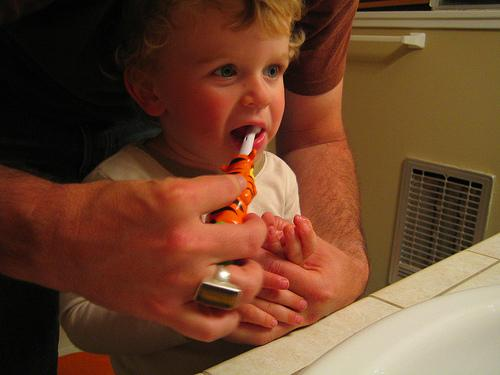Explain what the central figure in the image is engaged in. The center figure, a baby, is in the process of brushing his teeth using a toothbrush. What is the most important event happening in the image? Describe it. The key event in the image is a blond-haired baby brushing his teeth using a distinctive toothbrush. Mention the main subject of the image and their current activity. The image showcases a baby with blond hair brushing his teeth with an orange and white toothbrush. In one sentence, explain the main action of the primary character in the image. The main character, a baby with blond hair, is actively brushing his teeth with a toothbrush. In a concise manner, describe the most noticeable features in the image. The baby has blond hair, the man wears a brown shirt and silver ring, and there's a white porcelain sink. Briefly mention the major elements in the image and their interactions. A baby brushing teeth with an orange and white toothbrush, a man wearing a brown shirt and silver ring, and a white and porcelain sink. Identify the primary focus of the image and describe their activity. A baby with blond hair is brushing his teeth using an orange and white toothbrush. Write a short sentence summarizing the main action in the image. A blond baby is holding a toothbrush while brushing his teeth. Point out the key elements of the image and describe their connections. A baby is brushing teeth with a toothbrush, a man wears a brown shirt and ring, and a white sink is present in the background. Provide a brief overview of the primary objects and people in the image. Image features a baby brushing teeth, a man with brown shirt and silver ring, and various bathroom elements like a sink. 